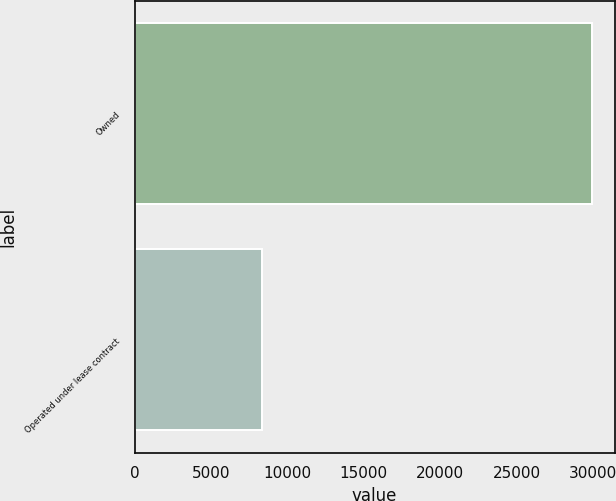Convert chart to OTSL. <chart><loc_0><loc_0><loc_500><loc_500><bar_chart><fcel>Owned<fcel>Operated under lease contract<nl><fcel>29924<fcel>8311<nl></chart> 